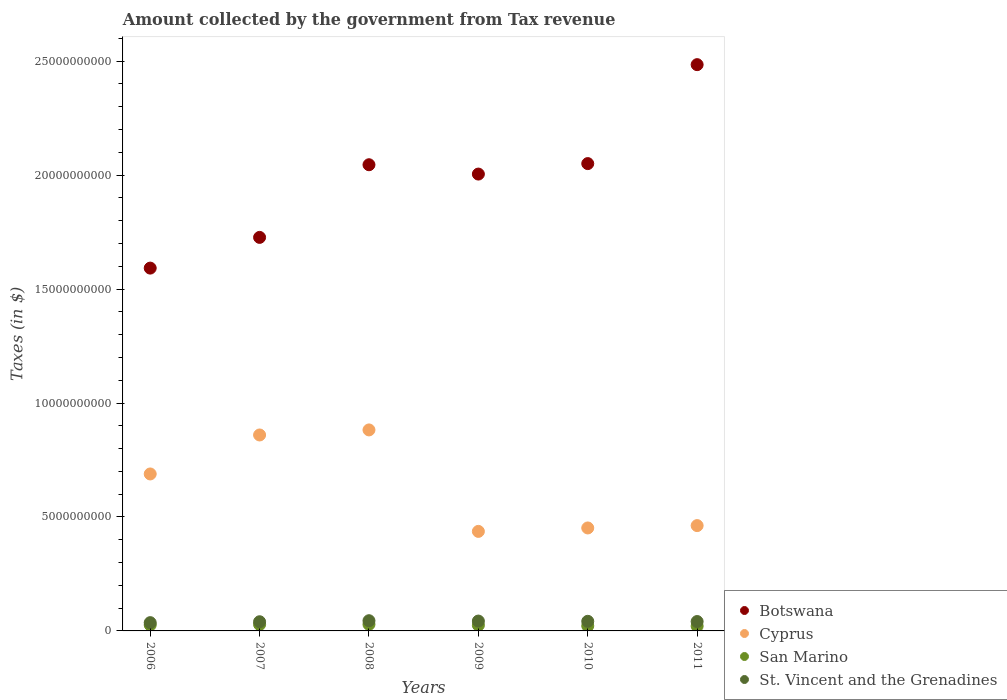Is the number of dotlines equal to the number of legend labels?
Your answer should be very brief. Yes. What is the amount collected by the government from tax revenue in St. Vincent and the Grenadines in 2011?
Your response must be concise. 4.12e+08. Across all years, what is the maximum amount collected by the government from tax revenue in San Marino?
Your answer should be compact. 2.89e+08. Across all years, what is the minimum amount collected by the government from tax revenue in San Marino?
Give a very brief answer. 2.10e+08. In which year was the amount collected by the government from tax revenue in San Marino minimum?
Give a very brief answer. 2011. What is the total amount collected by the government from tax revenue in San Marino in the graph?
Provide a succinct answer. 1.51e+09. What is the difference between the amount collected by the government from tax revenue in St. Vincent and the Grenadines in 2008 and that in 2009?
Your answer should be very brief. 1.54e+07. What is the difference between the amount collected by the government from tax revenue in San Marino in 2009 and the amount collected by the government from tax revenue in Botswana in 2008?
Your answer should be compact. -2.02e+1. What is the average amount collected by the government from tax revenue in Botswana per year?
Keep it short and to the point. 1.98e+1. In the year 2010, what is the difference between the amount collected by the government from tax revenue in San Marino and amount collected by the government from tax revenue in Cyprus?
Offer a very short reply. -4.30e+09. What is the ratio of the amount collected by the government from tax revenue in San Marino in 2006 to that in 2008?
Ensure brevity in your answer.  0.91. Is the difference between the amount collected by the government from tax revenue in San Marino in 2006 and 2011 greater than the difference between the amount collected by the government from tax revenue in Cyprus in 2006 and 2011?
Give a very brief answer. No. What is the difference between the highest and the second highest amount collected by the government from tax revenue in San Marino?
Keep it short and to the point. 7.06e+06. What is the difference between the highest and the lowest amount collected by the government from tax revenue in San Marino?
Ensure brevity in your answer.  7.83e+07. In how many years, is the amount collected by the government from tax revenue in Cyprus greater than the average amount collected by the government from tax revenue in Cyprus taken over all years?
Make the answer very short. 3. Is the sum of the amount collected by the government from tax revenue in St. Vincent and the Grenadines in 2006 and 2007 greater than the maximum amount collected by the government from tax revenue in San Marino across all years?
Give a very brief answer. Yes. Is it the case that in every year, the sum of the amount collected by the government from tax revenue in Cyprus and amount collected by the government from tax revenue in San Marino  is greater than the sum of amount collected by the government from tax revenue in St. Vincent and the Grenadines and amount collected by the government from tax revenue in Botswana?
Your answer should be compact. No. Is it the case that in every year, the sum of the amount collected by the government from tax revenue in St. Vincent and the Grenadines and amount collected by the government from tax revenue in San Marino  is greater than the amount collected by the government from tax revenue in Cyprus?
Provide a short and direct response. No. Does the amount collected by the government from tax revenue in Cyprus monotonically increase over the years?
Provide a succinct answer. No. Is the amount collected by the government from tax revenue in Botswana strictly greater than the amount collected by the government from tax revenue in San Marino over the years?
Your response must be concise. Yes. Is the amount collected by the government from tax revenue in San Marino strictly less than the amount collected by the government from tax revenue in St. Vincent and the Grenadines over the years?
Your response must be concise. Yes. How many years are there in the graph?
Provide a succinct answer. 6. What is the difference between two consecutive major ticks on the Y-axis?
Give a very brief answer. 5.00e+09. Where does the legend appear in the graph?
Keep it short and to the point. Bottom right. How many legend labels are there?
Make the answer very short. 4. How are the legend labels stacked?
Keep it short and to the point. Vertical. What is the title of the graph?
Make the answer very short. Amount collected by the government from Tax revenue. Does "Panama" appear as one of the legend labels in the graph?
Offer a very short reply. No. What is the label or title of the X-axis?
Ensure brevity in your answer.  Years. What is the label or title of the Y-axis?
Give a very brief answer. Taxes (in $). What is the Taxes (in $) in Botswana in 2006?
Make the answer very short. 1.59e+1. What is the Taxes (in $) of Cyprus in 2006?
Your answer should be compact. 6.89e+09. What is the Taxes (in $) of San Marino in 2006?
Your response must be concise. 2.62e+08. What is the Taxes (in $) of St. Vincent and the Grenadines in 2006?
Ensure brevity in your answer.  3.63e+08. What is the Taxes (in $) of Botswana in 2007?
Give a very brief answer. 1.73e+1. What is the Taxes (in $) in Cyprus in 2007?
Offer a very short reply. 8.60e+09. What is the Taxes (in $) in San Marino in 2007?
Keep it short and to the point. 2.82e+08. What is the Taxes (in $) of St. Vincent and the Grenadines in 2007?
Your response must be concise. 4.03e+08. What is the Taxes (in $) of Botswana in 2008?
Keep it short and to the point. 2.05e+1. What is the Taxes (in $) of Cyprus in 2008?
Ensure brevity in your answer.  8.82e+09. What is the Taxes (in $) in San Marino in 2008?
Your answer should be very brief. 2.89e+08. What is the Taxes (in $) of St. Vincent and the Grenadines in 2008?
Ensure brevity in your answer.  4.48e+08. What is the Taxes (in $) in Botswana in 2009?
Ensure brevity in your answer.  2.00e+1. What is the Taxes (in $) of Cyprus in 2009?
Your answer should be very brief. 4.37e+09. What is the Taxes (in $) of San Marino in 2009?
Ensure brevity in your answer.  2.51e+08. What is the Taxes (in $) of St. Vincent and the Grenadines in 2009?
Make the answer very short. 4.33e+08. What is the Taxes (in $) in Botswana in 2010?
Provide a succinct answer. 2.05e+1. What is the Taxes (in $) in Cyprus in 2010?
Give a very brief answer. 4.52e+09. What is the Taxes (in $) in San Marino in 2010?
Offer a terse response. 2.21e+08. What is the Taxes (in $) of St. Vincent and the Grenadines in 2010?
Your answer should be compact. 4.22e+08. What is the Taxes (in $) in Botswana in 2011?
Provide a short and direct response. 2.48e+1. What is the Taxes (in $) of Cyprus in 2011?
Offer a very short reply. 4.62e+09. What is the Taxes (in $) of San Marino in 2011?
Ensure brevity in your answer.  2.10e+08. What is the Taxes (in $) of St. Vincent and the Grenadines in 2011?
Provide a succinct answer. 4.12e+08. Across all years, what is the maximum Taxes (in $) in Botswana?
Your answer should be very brief. 2.48e+1. Across all years, what is the maximum Taxes (in $) in Cyprus?
Offer a very short reply. 8.82e+09. Across all years, what is the maximum Taxes (in $) in San Marino?
Ensure brevity in your answer.  2.89e+08. Across all years, what is the maximum Taxes (in $) of St. Vincent and the Grenadines?
Give a very brief answer. 4.48e+08. Across all years, what is the minimum Taxes (in $) of Botswana?
Offer a very short reply. 1.59e+1. Across all years, what is the minimum Taxes (in $) of Cyprus?
Keep it short and to the point. 4.37e+09. Across all years, what is the minimum Taxes (in $) of San Marino?
Give a very brief answer. 2.10e+08. Across all years, what is the minimum Taxes (in $) in St. Vincent and the Grenadines?
Make the answer very short. 3.63e+08. What is the total Taxes (in $) in Botswana in the graph?
Give a very brief answer. 1.19e+11. What is the total Taxes (in $) in Cyprus in the graph?
Make the answer very short. 3.78e+1. What is the total Taxes (in $) of San Marino in the graph?
Your answer should be very brief. 1.51e+09. What is the total Taxes (in $) of St. Vincent and the Grenadines in the graph?
Provide a succinct answer. 2.48e+09. What is the difference between the Taxes (in $) in Botswana in 2006 and that in 2007?
Provide a short and direct response. -1.35e+09. What is the difference between the Taxes (in $) of Cyprus in 2006 and that in 2007?
Provide a short and direct response. -1.71e+09. What is the difference between the Taxes (in $) in San Marino in 2006 and that in 2007?
Provide a succinct answer. -1.97e+07. What is the difference between the Taxes (in $) of St. Vincent and the Grenadines in 2006 and that in 2007?
Give a very brief answer. -3.98e+07. What is the difference between the Taxes (in $) of Botswana in 2006 and that in 2008?
Make the answer very short. -4.54e+09. What is the difference between the Taxes (in $) in Cyprus in 2006 and that in 2008?
Your response must be concise. -1.93e+09. What is the difference between the Taxes (in $) of San Marino in 2006 and that in 2008?
Make the answer very short. -2.68e+07. What is the difference between the Taxes (in $) in St. Vincent and the Grenadines in 2006 and that in 2008?
Ensure brevity in your answer.  -8.52e+07. What is the difference between the Taxes (in $) of Botswana in 2006 and that in 2009?
Keep it short and to the point. -4.13e+09. What is the difference between the Taxes (in $) in Cyprus in 2006 and that in 2009?
Your answer should be very brief. 2.52e+09. What is the difference between the Taxes (in $) in San Marino in 2006 and that in 2009?
Keep it short and to the point. 1.13e+07. What is the difference between the Taxes (in $) in St. Vincent and the Grenadines in 2006 and that in 2009?
Offer a terse response. -6.98e+07. What is the difference between the Taxes (in $) of Botswana in 2006 and that in 2010?
Give a very brief answer. -4.59e+09. What is the difference between the Taxes (in $) in Cyprus in 2006 and that in 2010?
Offer a terse response. 2.37e+09. What is the difference between the Taxes (in $) of San Marino in 2006 and that in 2010?
Your answer should be compact. 4.07e+07. What is the difference between the Taxes (in $) of St. Vincent and the Grenadines in 2006 and that in 2010?
Make the answer very short. -5.87e+07. What is the difference between the Taxes (in $) in Botswana in 2006 and that in 2011?
Offer a terse response. -8.93e+09. What is the difference between the Taxes (in $) in Cyprus in 2006 and that in 2011?
Provide a succinct answer. 2.27e+09. What is the difference between the Taxes (in $) in San Marino in 2006 and that in 2011?
Offer a terse response. 5.15e+07. What is the difference between the Taxes (in $) in St. Vincent and the Grenadines in 2006 and that in 2011?
Offer a very short reply. -4.93e+07. What is the difference between the Taxes (in $) in Botswana in 2007 and that in 2008?
Your response must be concise. -3.19e+09. What is the difference between the Taxes (in $) in Cyprus in 2007 and that in 2008?
Keep it short and to the point. -2.21e+08. What is the difference between the Taxes (in $) of San Marino in 2007 and that in 2008?
Your answer should be compact. -7.06e+06. What is the difference between the Taxes (in $) in St. Vincent and the Grenadines in 2007 and that in 2008?
Ensure brevity in your answer.  -4.54e+07. What is the difference between the Taxes (in $) of Botswana in 2007 and that in 2009?
Make the answer very short. -2.78e+09. What is the difference between the Taxes (in $) in Cyprus in 2007 and that in 2009?
Offer a terse response. 4.23e+09. What is the difference between the Taxes (in $) of San Marino in 2007 and that in 2009?
Give a very brief answer. 3.10e+07. What is the difference between the Taxes (in $) in St. Vincent and the Grenadines in 2007 and that in 2009?
Your answer should be very brief. -3.00e+07. What is the difference between the Taxes (in $) of Botswana in 2007 and that in 2010?
Give a very brief answer. -3.24e+09. What is the difference between the Taxes (in $) in Cyprus in 2007 and that in 2010?
Provide a short and direct response. 4.08e+09. What is the difference between the Taxes (in $) of San Marino in 2007 and that in 2010?
Your response must be concise. 6.04e+07. What is the difference between the Taxes (in $) in St. Vincent and the Grenadines in 2007 and that in 2010?
Provide a succinct answer. -1.89e+07. What is the difference between the Taxes (in $) of Botswana in 2007 and that in 2011?
Offer a very short reply. -7.58e+09. What is the difference between the Taxes (in $) in Cyprus in 2007 and that in 2011?
Provide a short and direct response. 3.98e+09. What is the difference between the Taxes (in $) in San Marino in 2007 and that in 2011?
Your answer should be very brief. 7.12e+07. What is the difference between the Taxes (in $) of St. Vincent and the Grenadines in 2007 and that in 2011?
Offer a terse response. -9.50e+06. What is the difference between the Taxes (in $) of Botswana in 2008 and that in 2009?
Offer a very short reply. 4.09e+08. What is the difference between the Taxes (in $) in Cyprus in 2008 and that in 2009?
Offer a very short reply. 4.45e+09. What is the difference between the Taxes (in $) in San Marino in 2008 and that in 2009?
Provide a short and direct response. 3.80e+07. What is the difference between the Taxes (in $) in St. Vincent and the Grenadines in 2008 and that in 2009?
Your answer should be very brief. 1.54e+07. What is the difference between the Taxes (in $) in Botswana in 2008 and that in 2010?
Make the answer very short. -5.03e+07. What is the difference between the Taxes (in $) in Cyprus in 2008 and that in 2010?
Keep it short and to the point. 4.30e+09. What is the difference between the Taxes (in $) in San Marino in 2008 and that in 2010?
Your answer should be compact. 6.75e+07. What is the difference between the Taxes (in $) of St. Vincent and the Grenadines in 2008 and that in 2010?
Provide a succinct answer. 2.65e+07. What is the difference between the Taxes (in $) of Botswana in 2008 and that in 2011?
Keep it short and to the point. -4.39e+09. What is the difference between the Taxes (in $) in Cyprus in 2008 and that in 2011?
Your answer should be very brief. 4.20e+09. What is the difference between the Taxes (in $) in San Marino in 2008 and that in 2011?
Your answer should be very brief. 7.83e+07. What is the difference between the Taxes (in $) in St. Vincent and the Grenadines in 2008 and that in 2011?
Keep it short and to the point. 3.59e+07. What is the difference between the Taxes (in $) of Botswana in 2009 and that in 2010?
Offer a very short reply. -4.60e+08. What is the difference between the Taxes (in $) of Cyprus in 2009 and that in 2010?
Keep it short and to the point. -1.51e+08. What is the difference between the Taxes (in $) in San Marino in 2009 and that in 2010?
Offer a terse response. 2.94e+07. What is the difference between the Taxes (in $) in St. Vincent and the Grenadines in 2009 and that in 2010?
Provide a short and direct response. 1.11e+07. What is the difference between the Taxes (in $) in Botswana in 2009 and that in 2011?
Keep it short and to the point. -4.80e+09. What is the difference between the Taxes (in $) of Cyprus in 2009 and that in 2011?
Your answer should be compact. -2.54e+08. What is the difference between the Taxes (in $) in San Marino in 2009 and that in 2011?
Your answer should be compact. 4.02e+07. What is the difference between the Taxes (in $) in St. Vincent and the Grenadines in 2009 and that in 2011?
Keep it short and to the point. 2.05e+07. What is the difference between the Taxes (in $) of Botswana in 2010 and that in 2011?
Provide a succinct answer. -4.34e+09. What is the difference between the Taxes (in $) of Cyprus in 2010 and that in 2011?
Your answer should be very brief. -1.04e+08. What is the difference between the Taxes (in $) in San Marino in 2010 and that in 2011?
Make the answer very short. 1.08e+07. What is the difference between the Taxes (in $) of St. Vincent and the Grenadines in 2010 and that in 2011?
Ensure brevity in your answer.  9.40e+06. What is the difference between the Taxes (in $) of Botswana in 2006 and the Taxes (in $) of Cyprus in 2007?
Make the answer very short. 7.32e+09. What is the difference between the Taxes (in $) of Botswana in 2006 and the Taxes (in $) of San Marino in 2007?
Provide a succinct answer. 1.56e+1. What is the difference between the Taxes (in $) in Botswana in 2006 and the Taxes (in $) in St. Vincent and the Grenadines in 2007?
Keep it short and to the point. 1.55e+1. What is the difference between the Taxes (in $) in Cyprus in 2006 and the Taxes (in $) in San Marino in 2007?
Your response must be concise. 6.61e+09. What is the difference between the Taxes (in $) of Cyprus in 2006 and the Taxes (in $) of St. Vincent and the Grenadines in 2007?
Offer a terse response. 6.48e+09. What is the difference between the Taxes (in $) in San Marino in 2006 and the Taxes (in $) in St. Vincent and the Grenadines in 2007?
Your answer should be compact. -1.41e+08. What is the difference between the Taxes (in $) in Botswana in 2006 and the Taxes (in $) in Cyprus in 2008?
Your answer should be compact. 7.10e+09. What is the difference between the Taxes (in $) in Botswana in 2006 and the Taxes (in $) in San Marino in 2008?
Offer a terse response. 1.56e+1. What is the difference between the Taxes (in $) of Botswana in 2006 and the Taxes (in $) of St. Vincent and the Grenadines in 2008?
Your answer should be very brief. 1.55e+1. What is the difference between the Taxes (in $) in Cyprus in 2006 and the Taxes (in $) in San Marino in 2008?
Your answer should be very brief. 6.60e+09. What is the difference between the Taxes (in $) of Cyprus in 2006 and the Taxes (in $) of St. Vincent and the Grenadines in 2008?
Make the answer very short. 6.44e+09. What is the difference between the Taxes (in $) of San Marino in 2006 and the Taxes (in $) of St. Vincent and the Grenadines in 2008?
Your answer should be very brief. -1.86e+08. What is the difference between the Taxes (in $) in Botswana in 2006 and the Taxes (in $) in Cyprus in 2009?
Provide a short and direct response. 1.16e+1. What is the difference between the Taxes (in $) in Botswana in 2006 and the Taxes (in $) in San Marino in 2009?
Make the answer very short. 1.57e+1. What is the difference between the Taxes (in $) in Botswana in 2006 and the Taxes (in $) in St. Vincent and the Grenadines in 2009?
Offer a very short reply. 1.55e+1. What is the difference between the Taxes (in $) of Cyprus in 2006 and the Taxes (in $) of San Marino in 2009?
Your response must be concise. 6.64e+09. What is the difference between the Taxes (in $) in Cyprus in 2006 and the Taxes (in $) in St. Vincent and the Grenadines in 2009?
Your response must be concise. 6.45e+09. What is the difference between the Taxes (in $) of San Marino in 2006 and the Taxes (in $) of St. Vincent and the Grenadines in 2009?
Your answer should be compact. -1.71e+08. What is the difference between the Taxes (in $) in Botswana in 2006 and the Taxes (in $) in Cyprus in 2010?
Your response must be concise. 1.14e+1. What is the difference between the Taxes (in $) in Botswana in 2006 and the Taxes (in $) in San Marino in 2010?
Your answer should be compact. 1.57e+1. What is the difference between the Taxes (in $) in Botswana in 2006 and the Taxes (in $) in St. Vincent and the Grenadines in 2010?
Keep it short and to the point. 1.55e+1. What is the difference between the Taxes (in $) in Cyprus in 2006 and the Taxes (in $) in San Marino in 2010?
Offer a terse response. 6.67e+09. What is the difference between the Taxes (in $) of Cyprus in 2006 and the Taxes (in $) of St. Vincent and the Grenadines in 2010?
Make the answer very short. 6.47e+09. What is the difference between the Taxes (in $) in San Marino in 2006 and the Taxes (in $) in St. Vincent and the Grenadines in 2010?
Your answer should be very brief. -1.60e+08. What is the difference between the Taxes (in $) of Botswana in 2006 and the Taxes (in $) of Cyprus in 2011?
Make the answer very short. 1.13e+1. What is the difference between the Taxes (in $) of Botswana in 2006 and the Taxes (in $) of San Marino in 2011?
Provide a short and direct response. 1.57e+1. What is the difference between the Taxes (in $) of Botswana in 2006 and the Taxes (in $) of St. Vincent and the Grenadines in 2011?
Provide a succinct answer. 1.55e+1. What is the difference between the Taxes (in $) in Cyprus in 2006 and the Taxes (in $) in San Marino in 2011?
Your answer should be compact. 6.68e+09. What is the difference between the Taxes (in $) of Cyprus in 2006 and the Taxes (in $) of St. Vincent and the Grenadines in 2011?
Ensure brevity in your answer.  6.47e+09. What is the difference between the Taxes (in $) of San Marino in 2006 and the Taxes (in $) of St. Vincent and the Grenadines in 2011?
Make the answer very short. -1.50e+08. What is the difference between the Taxes (in $) of Botswana in 2007 and the Taxes (in $) of Cyprus in 2008?
Your response must be concise. 8.45e+09. What is the difference between the Taxes (in $) of Botswana in 2007 and the Taxes (in $) of San Marino in 2008?
Make the answer very short. 1.70e+1. What is the difference between the Taxes (in $) of Botswana in 2007 and the Taxes (in $) of St. Vincent and the Grenadines in 2008?
Offer a terse response. 1.68e+1. What is the difference between the Taxes (in $) in Cyprus in 2007 and the Taxes (in $) in San Marino in 2008?
Make the answer very short. 8.31e+09. What is the difference between the Taxes (in $) of Cyprus in 2007 and the Taxes (in $) of St. Vincent and the Grenadines in 2008?
Give a very brief answer. 8.15e+09. What is the difference between the Taxes (in $) in San Marino in 2007 and the Taxes (in $) in St. Vincent and the Grenadines in 2008?
Provide a short and direct response. -1.66e+08. What is the difference between the Taxes (in $) in Botswana in 2007 and the Taxes (in $) in Cyprus in 2009?
Keep it short and to the point. 1.29e+1. What is the difference between the Taxes (in $) of Botswana in 2007 and the Taxes (in $) of San Marino in 2009?
Your answer should be very brief. 1.70e+1. What is the difference between the Taxes (in $) of Botswana in 2007 and the Taxes (in $) of St. Vincent and the Grenadines in 2009?
Your answer should be compact. 1.68e+1. What is the difference between the Taxes (in $) of Cyprus in 2007 and the Taxes (in $) of San Marino in 2009?
Provide a short and direct response. 8.35e+09. What is the difference between the Taxes (in $) of Cyprus in 2007 and the Taxes (in $) of St. Vincent and the Grenadines in 2009?
Ensure brevity in your answer.  8.17e+09. What is the difference between the Taxes (in $) in San Marino in 2007 and the Taxes (in $) in St. Vincent and the Grenadines in 2009?
Your response must be concise. -1.51e+08. What is the difference between the Taxes (in $) of Botswana in 2007 and the Taxes (in $) of Cyprus in 2010?
Your response must be concise. 1.27e+1. What is the difference between the Taxes (in $) of Botswana in 2007 and the Taxes (in $) of San Marino in 2010?
Give a very brief answer. 1.70e+1. What is the difference between the Taxes (in $) of Botswana in 2007 and the Taxes (in $) of St. Vincent and the Grenadines in 2010?
Provide a short and direct response. 1.68e+1. What is the difference between the Taxes (in $) of Cyprus in 2007 and the Taxes (in $) of San Marino in 2010?
Offer a very short reply. 8.38e+09. What is the difference between the Taxes (in $) of Cyprus in 2007 and the Taxes (in $) of St. Vincent and the Grenadines in 2010?
Give a very brief answer. 8.18e+09. What is the difference between the Taxes (in $) of San Marino in 2007 and the Taxes (in $) of St. Vincent and the Grenadines in 2010?
Your response must be concise. -1.40e+08. What is the difference between the Taxes (in $) of Botswana in 2007 and the Taxes (in $) of Cyprus in 2011?
Provide a succinct answer. 1.26e+1. What is the difference between the Taxes (in $) in Botswana in 2007 and the Taxes (in $) in San Marino in 2011?
Provide a succinct answer. 1.71e+1. What is the difference between the Taxes (in $) in Botswana in 2007 and the Taxes (in $) in St. Vincent and the Grenadines in 2011?
Your response must be concise. 1.69e+1. What is the difference between the Taxes (in $) in Cyprus in 2007 and the Taxes (in $) in San Marino in 2011?
Provide a short and direct response. 8.39e+09. What is the difference between the Taxes (in $) in Cyprus in 2007 and the Taxes (in $) in St. Vincent and the Grenadines in 2011?
Your response must be concise. 8.19e+09. What is the difference between the Taxes (in $) in San Marino in 2007 and the Taxes (in $) in St. Vincent and the Grenadines in 2011?
Offer a terse response. -1.30e+08. What is the difference between the Taxes (in $) of Botswana in 2008 and the Taxes (in $) of Cyprus in 2009?
Keep it short and to the point. 1.61e+1. What is the difference between the Taxes (in $) of Botswana in 2008 and the Taxes (in $) of San Marino in 2009?
Your answer should be very brief. 2.02e+1. What is the difference between the Taxes (in $) in Botswana in 2008 and the Taxes (in $) in St. Vincent and the Grenadines in 2009?
Provide a short and direct response. 2.00e+1. What is the difference between the Taxes (in $) of Cyprus in 2008 and the Taxes (in $) of San Marino in 2009?
Make the answer very short. 8.57e+09. What is the difference between the Taxes (in $) of Cyprus in 2008 and the Taxes (in $) of St. Vincent and the Grenadines in 2009?
Provide a short and direct response. 8.39e+09. What is the difference between the Taxes (in $) of San Marino in 2008 and the Taxes (in $) of St. Vincent and the Grenadines in 2009?
Provide a succinct answer. -1.44e+08. What is the difference between the Taxes (in $) in Botswana in 2008 and the Taxes (in $) in Cyprus in 2010?
Your response must be concise. 1.59e+1. What is the difference between the Taxes (in $) in Botswana in 2008 and the Taxes (in $) in San Marino in 2010?
Provide a succinct answer. 2.02e+1. What is the difference between the Taxes (in $) of Botswana in 2008 and the Taxes (in $) of St. Vincent and the Grenadines in 2010?
Offer a terse response. 2.00e+1. What is the difference between the Taxes (in $) in Cyprus in 2008 and the Taxes (in $) in San Marino in 2010?
Provide a short and direct response. 8.60e+09. What is the difference between the Taxes (in $) of Cyprus in 2008 and the Taxes (in $) of St. Vincent and the Grenadines in 2010?
Offer a very short reply. 8.40e+09. What is the difference between the Taxes (in $) of San Marino in 2008 and the Taxes (in $) of St. Vincent and the Grenadines in 2010?
Offer a terse response. -1.33e+08. What is the difference between the Taxes (in $) of Botswana in 2008 and the Taxes (in $) of Cyprus in 2011?
Ensure brevity in your answer.  1.58e+1. What is the difference between the Taxes (in $) of Botswana in 2008 and the Taxes (in $) of San Marino in 2011?
Your answer should be very brief. 2.02e+1. What is the difference between the Taxes (in $) in Botswana in 2008 and the Taxes (in $) in St. Vincent and the Grenadines in 2011?
Provide a short and direct response. 2.00e+1. What is the difference between the Taxes (in $) in Cyprus in 2008 and the Taxes (in $) in San Marino in 2011?
Keep it short and to the point. 8.61e+09. What is the difference between the Taxes (in $) in Cyprus in 2008 and the Taxes (in $) in St. Vincent and the Grenadines in 2011?
Provide a short and direct response. 8.41e+09. What is the difference between the Taxes (in $) of San Marino in 2008 and the Taxes (in $) of St. Vincent and the Grenadines in 2011?
Provide a succinct answer. -1.23e+08. What is the difference between the Taxes (in $) of Botswana in 2009 and the Taxes (in $) of Cyprus in 2010?
Make the answer very short. 1.55e+1. What is the difference between the Taxes (in $) of Botswana in 2009 and the Taxes (in $) of San Marino in 2010?
Provide a short and direct response. 1.98e+1. What is the difference between the Taxes (in $) of Botswana in 2009 and the Taxes (in $) of St. Vincent and the Grenadines in 2010?
Ensure brevity in your answer.  1.96e+1. What is the difference between the Taxes (in $) of Cyprus in 2009 and the Taxes (in $) of San Marino in 2010?
Provide a succinct answer. 4.15e+09. What is the difference between the Taxes (in $) of Cyprus in 2009 and the Taxes (in $) of St. Vincent and the Grenadines in 2010?
Ensure brevity in your answer.  3.95e+09. What is the difference between the Taxes (in $) in San Marino in 2009 and the Taxes (in $) in St. Vincent and the Grenadines in 2010?
Offer a very short reply. -1.71e+08. What is the difference between the Taxes (in $) in Botswana in 2009 and the Taxes (in $) in Cyprus in 2011?
Offer a very short reply. 1.54e+1. What is the difference between the Taxes (in $) of Botswana in 2009 and the Taxes (in $) of San Marino in 2011?
Offer a terse response. 1.98e+1. What is the difference between the Taxes (in $) in Botswana in 2009 and the Taxes (in $) in St. Vincent and the Grenadines in 2011?
Provide a short and direct response. 1.96e+1. What is the difference between the Taxes (in $) of Cyprus in 2009 and the Taxes (in $) of San Marino in 2011?
Offer a very short reply. 4.16e+09. What is the difference between the Taxes (in $) of Cyprus in 2009 and the Taxes (in $) of St. Vincent and the Grenadines in 2011?
Offer a terse response. 3.96e+09. What is the difference between the Taxes (in $) of San Marino in 2009 and the Taxes (in $) of St. Vincent and the Grenadines in 2011?
Your answer should be compact. -1.61e+08. What is the difference between the Taxes (in $) in Botswana in 2010 and the Taxes (in $) in Cyprus in 2011?
Your response must be concise. 1.59e+1. What is the difference between the Taxes (in $) in Botswana in 2010 and the Taxes (in $) in San Marino in 2011?
Offer a terse response. 2.03e+1. What is the difference between the Taxes (in $) of Botswana in 2010 and the Taxes (in $) of St. Vincent and the Grenadines in 2011?
Provide a succinct answer. 2.01e+1. What is the difference between the Taxes (in $) in Cyprus in 2010 and the Taxes (in $) in San Marino in 2011?
Offer a very short reply. 4.31e+09. What is the difference between the Taxes (in $) in Cyprus in 2010 and the Taxes (in $) in St. Vincent and the Grenadines in 2011?
Your response must be concise. 4.11e+09. What is the difference between the Taxes (in $) of San Marino in 2010 and the Taxes (in $) of St. Vincent and the Grenadines in 2011?
Keep it short and to the point. -1.91e+08. What is the average Taxes (in $) of Botswana per year?
Provide a succinct answer. 1.98e+1. What is the average Taxes (in $) of Cyprus per year?
Keep it short and to the point. 6.30e+09. What is the average Taxes (in $) in San Marino per year?
Your answer should be compact. 2.52e+08. What is the average Taxes (in $) in St. Vincent and the Grenadines per year?
Your answer should be compact. 4.13e+08. In the year 2006, what is the difference between the Taxes (in $) of Botswana and Taxes (in $) of Cyprus?
Your response must be concise. 9.03e+09. In the year 2006, what is the difference between the Taxes (in $) of Botswana and Taxes (in $) of San Marino?
Your response must be concise. 1.57e+1. In the year 2006, what is the difference between the Taxes (in $) in Botswana and Taxes (in $) in St. Vincent and the Grenadines?
Your answer should be compact. 1.56e+1. In the year 2006, what is the difference between the Taxes (in $) of Cyprus and Taxes (in $) of San Marino?
Provide a succinct answer. 6.63e+09. In the year 2006, what is the difference between the Taxes (in $) in Cyprus and Taxes (in $) in St. Vincent and the Grenadines?
Make the answer very short. 6.52e+09. In the year 2006, what is the difference between the Taxes (in $) in San Marino and Taxes (in $) in St. Vincent and the Grenadines?
Make the answer very short. -1.01e+08. In the year 2007, what is the difference between the Taxes (in $) in Botswana and Taxes (in $) in Cyprus?
Your response must be concise. 8.67e+09. In the year 2007, what is the difference between the Taxes (in $) of Botswana and Taxes (in $) of San Marino?
Provide a succinct answer. 1.70e+1. In the year 2007, what is the difference between the Taxes (in $) in Botswana and Taxes (in $) in St. Vincent and the Grenadines?
Your answer should be compact. 1.69e+1. In the year 2007, what is the difference between the Taxes (in $) of Cyprus and Taxes (in $) of San Marino?
Keep it short and to the point. 8.32e+09. In the year 2007, what is the difference between the Taxes (in $) of Cyprus and Taxes (in $) of St. Vincent and the Grenadines?
Your response must be concise. 8.20e+09. In the year 2007, what is the difference between the Taxes (in $) in San Marino and Taxes (in $) in St. Vincent and the Grenadines?
Your answer should be very brief. -1.21e+08. In the year 2008, what is the difference between the Taxes (in $) of Botswana and Taxes (in $) of Cyprus?
Give a very brief answer. 1.16e+1. In the year 2008, what is the difference between the Taxes (in $) of Botswana and Taxes (in $) of San Marino?
Ensure brevity in your answer.  2.02e+1. In the year 2008, what is the difference between the Taxes (in $) of Botswana and Taxes (in $) of St. Vincent and the Grenadines?
Ensure brevity in your answer.  2.00e+1. In the year 2008, what is the difference between the Taxes (in $) in Cyprus and Taxes (in $) in San Marino?
Give a very brief answer. 8.53e+09. In the year 2008, what is the difference between the Taxes (in $) in Cyprus and Taxes (in $) in St. Vincent and the Grenadines?
Provide a succinct answer. 8.37e+09. In the year 2008, what is the difference between the Taxes (in $) in San Marino and Taxes (in $) in St. Vincent and the Grenadines?
Provide a short and direct response. -1.59e+08. In the year 2009, what is the difference between the Taxes (in $) of Botswana and Taxes (in $) of Cyprus?
Offer a terse response. 1.57e+1. In the year 2009, what is the difference between the Taxes (in $) of Botswana and Taxes (in $) of San Marino?
Make the answer very short. 1.98e+1. In the year 2009, what is the difference between the Taxes (in $) of Botswana and Taxes (in $) of St. Vincent and the Grenadines?
Keep it short and to the point. 1.96e+1. In the year 2009, what is the difference between the Taxes (in $) of Cyprus and Taxes (in $) of San Marino?
Your answer should be very brief. 4.12e+09. In the year 2009, what is the difference between the Taxes (in $) of Cyprus and Taxes (in $) of St. Vincent and the Grenadines?
Offer a very short reply. 3.93e+09. In the year 2009, what is the difference between the Taxes (in $) in San Marino and Taxes (in $) in St. Vincent and the Grenadines?
Offer a very short reply. -1.82e+08. In the year 2010, what is the difference between the Taxes (in $) of Botswana and Taxes (in $) of Cyprus?
Give a very brief answer. 1.60e+1. In the year 2010, what is the difference between the Taxes (in $) in Botswana and Taxes (in $) in San Marino?
Your answer should be compact. 2.03e+1. In the year 2010, what is the difference between the Taxes (in $) of Botswana and Taxes (in $) of St. Vincent and the Grenadines?
Provide a short and direct response. 2.01e+1. In the year 2010, what is the difference between the Taxes (in $) of Cyprus and Taxes (in $) of San Marino?
Provide a short and direct response. 4.30e+09. In the year 2010, what is the difference between the Taxes (in $) of Cyprus and Taxes (in $) of St. Vincent and the Grenadines?
Provide a short and direct response. 4.10e+09. In the year 2010, what is the difference between the Taxes (in $) of San Marino and Taxes (in $) of St. Vincent and the Grenadines?
Your response must be concise. -2.00e+08. In the year 2011, what is the difference between the Taxes (in $) in Botswana and Taxes (in $) in Cyprus?
Provide a succinct answer. 2.02e+1. In the year 2011, what is the difference between the Taxes (in $) in Botswana and Taxes (in $) in San Marino?
Your response must be concise. 2.46e+1. In the year 2011, what is the difference between the Taxes (in $) of Botswana and Taxes (in $) of St. Vincent and the Grenadines?
Provide a succinct answer. 2.44e+1. In the year 2011, what is the difference between the Taxes (in $) in Cyprus and Taxes (in $) in San Marino?
Your answer should be very brief. 4.41e+09. In the year 2011, what is the difference between the Taxes (in $) in Cyprus and Taxes (in $) in St. Vincent and the Grenadines?
Ensure brevity in your answer.  4.21e+09. In the year 2011, what is the difference between the Taxes (in $) in San Marino and Taxes (in $) in St. Vincent and the Grenadines?
Provide a succinct answer. -2.02e+08. What is the ratio of the Taxes (in $) in Botswana in 2006 to that in 2007?
Give a very brief answer. 0.92. What is the ratio of the Taxes (in $) of Cyprus in 2006 to that in 2007?
Ensure brevity in your answer.  0.8. What is the ratio of the Taxes (in $) in San Marino in 2006 to that in 2007?
Your answer should be very brief. 0.93. What is the ratio of the Taxes (in $) in St. Vincent and the Grenadines in 2006 to that in 2007?
Your response must be concise. 0.9. What is the ratio of the Taxes (in $) of Botswana in 2006 to that in 2008?
Your answer should be very brief. 0.78. What is the ratio of the Taxes (in $) of Cyprus in 2006 to that in 2008?
Provide a short and direct response. 0.78. What is the ratio of the Taxes (in $) of San Marino in 2006 to that in 2008?
Give a very brief answer. 0.91. What is the ratio of the Taxes (in $) of St. Vincent and the Grenadines in 2006 to that in 2008?
Your answer should be compact. 0.81. What is the ratio of the Taxes (in $) of Botswana in 2006 to that in 2009?
Your answer should be very brief. 0.79. What is the ratio of the Taxes (in $) in Cyprus in 2006 to that in 2009?
Provide a succinct answer. 1.58. What is the ratio of the Taxes (in $) in San Marino in 2006 to that in 2009?
Give a very brief answer. 1.04. What is the ratio of the Taxes (in $) of St. Vincent and the Grenadines in 2006 to that in 2009?
Your answer should be compact. 0.84. What is the ratio of the Taxes (in $) in Botswana in 2006 to that in 2010?
Give a very brief answer. 0.78. What is the ratio of the Taxes (in $) of Cyprus in 2006 to that in 2010?
Provide a short and direct response. 1.52. What is the ratio of the Taxes (in $) of San Marino in 2006 to that in 2010?
Ensure brevity in your answer.  1.18. What is the ratio of the Taxes (in $) of St. Vincent and the Grenadines in 2006 to that in 2010?
Offer a very short reply. 0.86. What is the ratio of the Taxes (in $) of Botswana in 2006 to that in 2011?
Provide a succinct answer. 0.64. What is the ratio of the Taxes (in $) in Cyprus in 2006 to that in 2011?
Offer a terse response. 1.49. What is the ratio of the Taxes (in $) of San Marino in 2006 to that in 2011?
Your answer should be compact. 1.24. What is the ratio of the Taxes (in $) of St. Vincent and the Grenadines in 2006 to that in 2011?
Ensure brevity in your answer.  0.88. What is the ratio of the Taxes (in $) in Botswana in 2007 to that in 2008?
Offer a terse response. 0.84. What is the ratio of the Taxes (in $) in Cyprus in 2007 to that in 2008?
Provide a short and direct response. 0.97. What is the ratio of the Taxes (in $) in San Marino in 2007 to that in 2008?
Offer a very short reply. 0.98. What is the ratio of the Taxes (in $) in St. Vincent and the Grenadines in 2007 to that in 2008?
Make the answer very short. 0.9. What is the ratio of the Taxes (in $) of Botswana in 2007 to that in 2009?
Your response must be concise. 0.86. What is the ratio of the Taxes (in $) in Cyprus in 2007 to that in 2009?
Offer a terse response. 1.97. What is the ratio of the Taxes (in $) of San Marino in 2007 to that in 2009?
Give a very brief answer. 1.12. What is the ratio of the Taxes (in $) of St. Vincent and the Grenadines in 2007 to that in 2009?
Offer a very short reply. 0.93. What is the ratio of the Taxes (in $) in Botswana in 2007 to that in 2010?
Your answer should be very brief. 0.84. What is the ratio of the Taxes (in $) of Cyprus in 2007 to that in 2010?
Keep it short and to the point. 1.9. What is the ratio of the Taxes (in $) of San Marino in 2007 to that in 2010?
Offer a very short reply. 1.27. What is the ratio of the Taxes (in $) in St. Vincent and the Grenadines in 2007 to that in 2010?
Provide a short and direct response. 0.96. What is the ratio of the Taxes (in $) of Botswana in 2007 to that in 2011?
Your answer should be compact. 0.69. What is the ratio of the Taxes (in $) in Cyprus in 2007 to that in 2011?
Give a very brief answer. 1.86. What is the ratio of the Taxes (in $) in San Marino in 2007 to that in 2011?
Your answer should be very brief. 1.34. What is the ratio of the Taxes (in $) in St. Vincent and the Grenadines in 2007 to that in 2011?
Your answer should be very brief. 0.98. What is the ratio of the Taxes (in $) of Botswana in 2008 to that in 2009?
Ensure brevity in your answer.  1.02. What is the ratio of the Taxes (in $) of Cyprus in 2008 to that in 2009?
Offer a terse response. 2.02. What is the ratio of the Taxes (in $) in San Marino in 2008 to that in 2009?
Your answer should be compact. 1.15. What is the ratio of the Taxes (in $) in St. Vincent and the Grenadines in 2008 to that in 2009?
Provide a succinct answer. 1.04. What is the ratio of the Taxes (in $) in Cyprus in 2008 to that in 2010?
Provide a succinct answer. 1.95. What is the ratio of the Taxes (in $) in San Marino in 2008 to that in 2010?
Give a very brief answer. 1.3. What is the ratio of the Taxes (in $) in St. Vincent and the Grenadines in 2008 to that in 2010?
Provide a short and direct response. 1.06. What is the ratio of the Taxes (in $) of Botswana in 2008 to that in 2011?
Provide a succinct answer. 0.82. What is the ratio of the Taxes (in $) in Cyprus in 2008 to that in 2011?
Make the answer very short. 1.91. What is the ratio of the Taxes (in $) of San Marino in 2008 to that in 2011?
Provide a short and direct response. 1.37. What is the ratio of the Taxes (in $) of St. Vincent and the Grenadines in 2008 to that in 2011?
Your response must be concise. 1.09. What is the ratio of the Taxes (in $) in Botswana in 2009 to that in 2010?
Ensure brevity in your answer.  0.98. What is the ratio of the Taxes (in $) of Cyprus in 2009 to that in 2010?
Your answer should be very brief. 0.97. What is the ratio of the Taxes (in $) in San Marino in 2009 to that in 2010?
Your answer should be very brief. 1.13. What is the ratio of the Taxes (in $) of St. Vincent and the Grenadines in 2009 to that in 2010?
Make the answer very short. 1.03. What is the ratio of the Taxes (in $) of Botswana in 2009 to that in 2011?
Ensure brevity in your answer.  0.81. What is the ratio of the Taxes (in $) in Cyprus in 2009 to that in 2011?
Provide a short and direct response. 0.94. What is the ratio of the Taxes (in $) in San Marino in 2009 to that in 2011?
Offer a very short reply. 1.19. What is the ratio of the Taxes (in $) in St. Vincent and the Grenadines in 2009 to that in 2011?
Provide a short and direct response. 1.05. What is the ratio of the Taxes (in $) in Botswana in 2010 to that in 2011?
Keep it short and to the point. 0.83. What is the ratio of the Taxes (in $) in Cyprus in 2010 to that in 2011?
Ensure brevity in your answer.  0.98. What is the ratio of the Taxes (in $) in San Marino in 2010 to that in 2011?
Make the answer very short. 1.05. What is the ratio of the Taxes (in $) in St. Vincent and the Grenadines in 2010 to that in 2011?
Your answer should be compact. 1.02. What is the difference between the highest and the second highest Taxes (in $) in Botswana?
Your response must be concise. 4.34e+09. What is the difference between the highest and the second highest Taxes (in $) in Cyprus?
Offer a very short reply. 2.21e+08. What is the difference between the highest and the second highest Taxes (in $) of San Marino?
Make the answer very short. 7.06e+06. What is the difference between the highest and the second highest Taxes (in $) in St. Vincent and the Grenadines?
Provide a short and direct response. 1.54e+07. What is the difference between the highest and the lowest Taxes (in $) in Botswana?
Offer a terse response. 8.93e+09. What is the difference between the highest and the lowest Taxes (in $) of Cyprus?
Give a very brief answer. 4.45e+09. What is the difference between the highest and the lowest Taxes (in $) of San Marino?
Make the answer very short. 7.83e+07. What is the difference between the highest and the lowest Taxes (in $) of St. Vincent and the Grenadines?
Provide a short and direct response. 8.52e+07. 